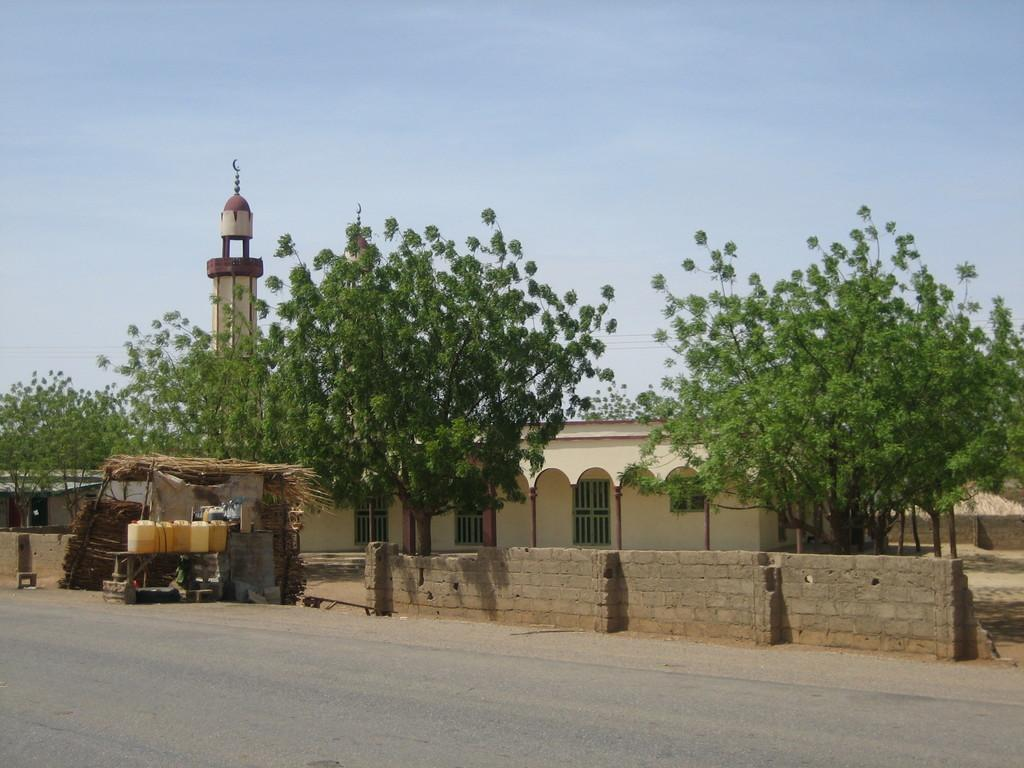What is the main feature of the image? There is a road in the image. What objects can be seen near the road? There are cans and a hut visible in the image. What structures are present in the image? There is a wall and a building in the image. What can be seen in the background of the image? There is a house, trees, and the sky visible in the background of the image. How many objects are present in the image? There are multiple objects in the image, including cans, a hut, a wall, a building, and more. What type of kettle is being used to make tea in the image? There is no kettle present in the image; it features a road, cans, a hut, a wall, a building, and more. Is the person in the image sleeping or awake? There is no person visible in the image, so it cannot be determined if someone is sleeping or awake. 